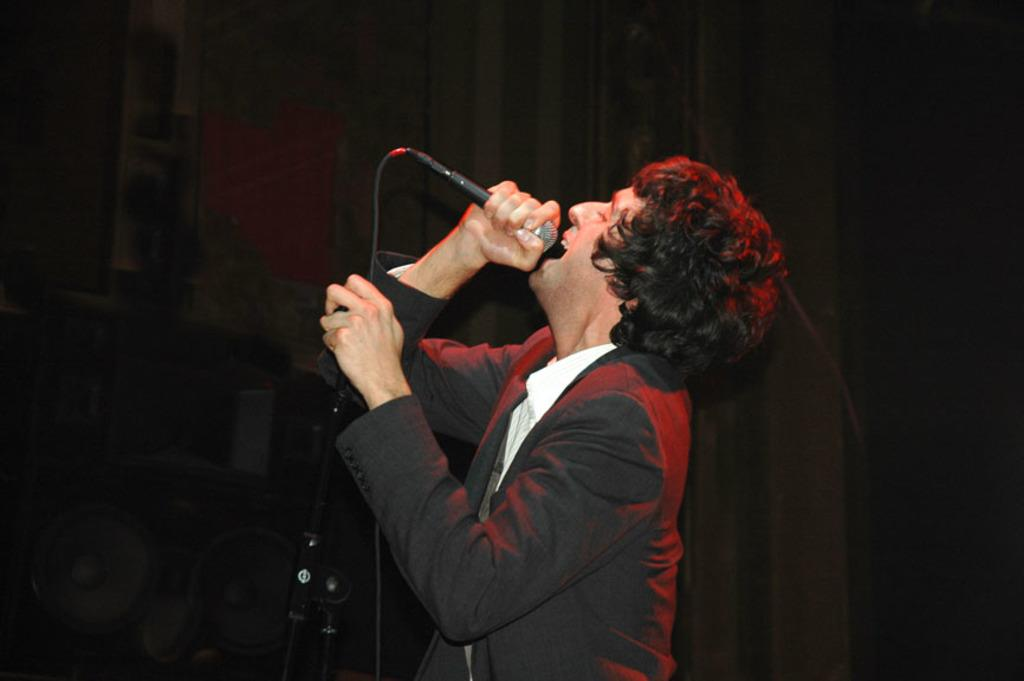What is the man in the image holding? The man is holding a mic. What can be seen in the background of the image? There is a cloth, a wall, and other objects visible in the background of the image. Are there any cobwebs visible in the image? There is no mention of cobwebs in the provided facts, so we cannot determine if any are present in the image. 